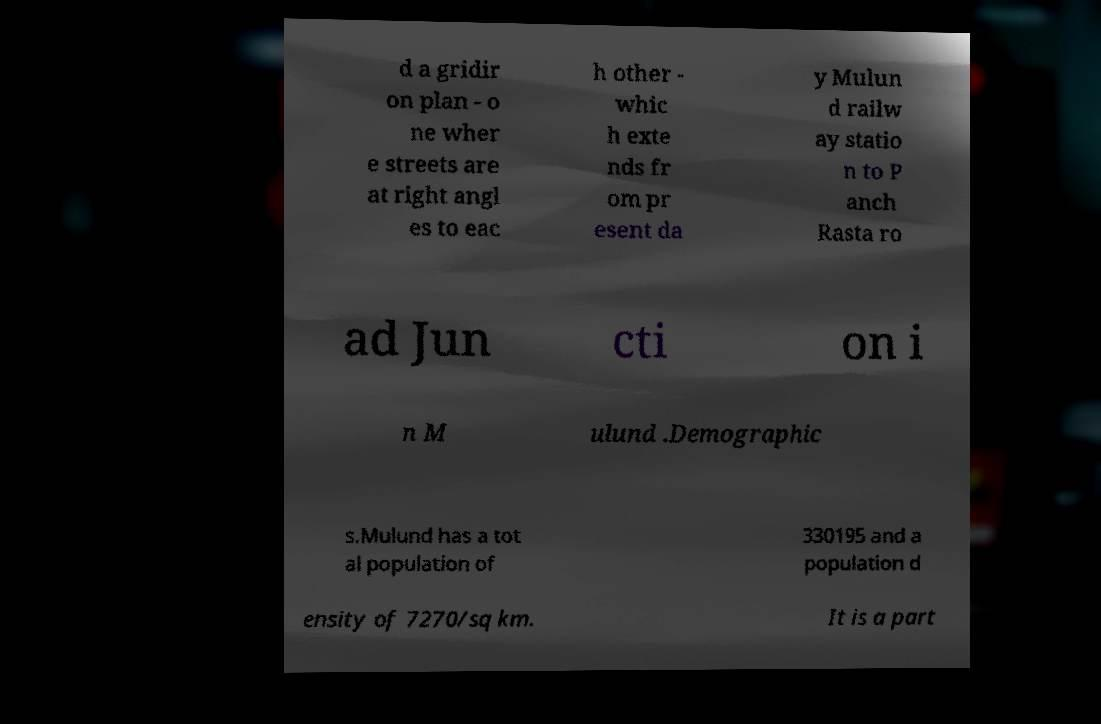There's text embedded in this image that I need extracted. Can you transcribe it verbatim? d a gridir on plan - o ne wher e streets are at right angl es to eac h other - whic h exte nds fr om pr esent da y Mulun d railw ay statio n to P anch Rasta ro ad Jun cti on i n M ulund .Demographic s.Mulund has a tot al population of 330195 and a population d ensity of 7270/sq km. It is a part 